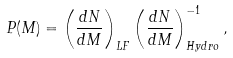<formula> <loc_0><loc_0><loc_500><loc_500>P ( M ) = \left ( \frac { d N } { d M } \right ) _ { L F } \left ( \frac { d N } { d M } \right ) _ { H y d r o } ^ { - 1 } ,</formula> 